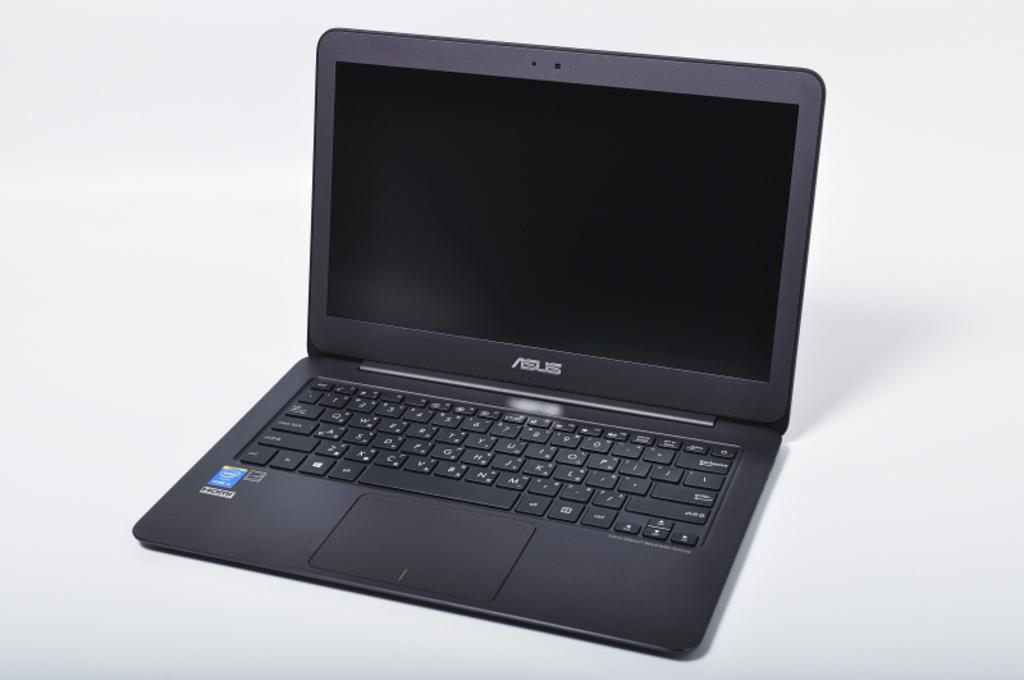<image>
Share a concise interpretation of the image provided. a computer with the words HD on the corner of it 